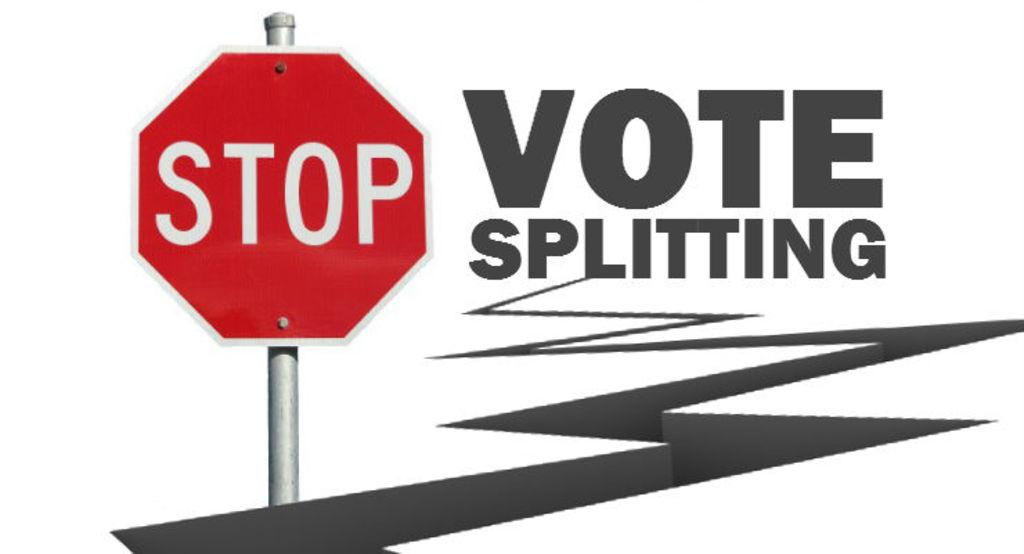<image>
Share a concise interpretation of the image provided. A stop sign next to a slogan reading Vote Splitting. 